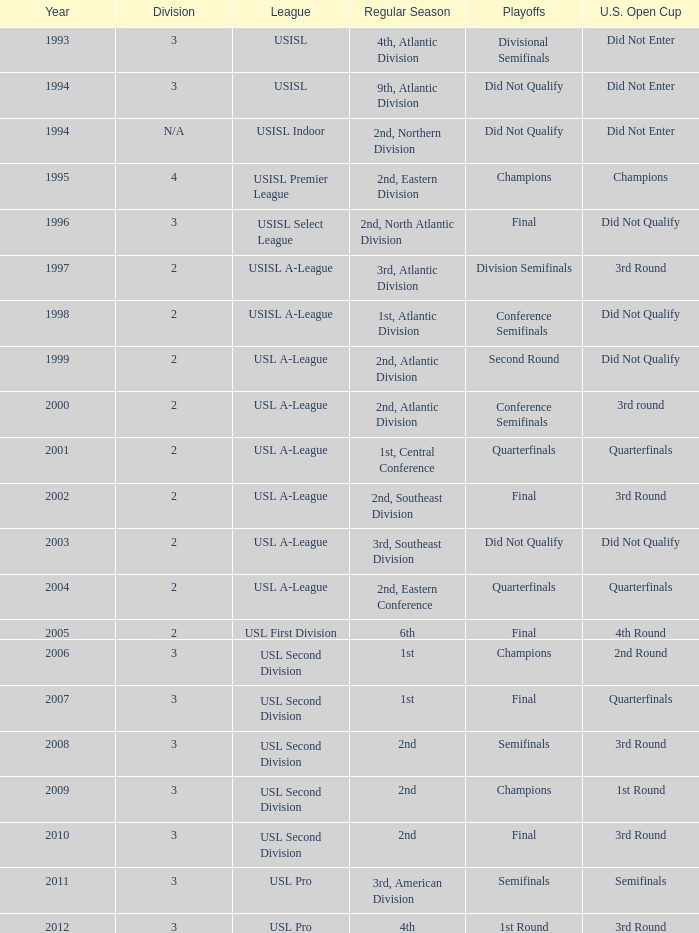Can you list the 1st round playoff games for the u.s. open cup? Champions. Write the full table. {'header': ['Year', 'Division', 'League', 'Regular Season', 'Playoffs', 'U.S. Open Cup'], 'rows': [['1993', '3', 'USISL', '4th, Atlantic Division', 'Divisional Semifinals', 'Did Not Enter'], ['1994', '3', 'USISL', '9th, Atlantic Division', 'Did Not Qualify', 'Did Not Enter'], ['1994', 'N/A', 'USISL Indoor', '2nd, Northern Division', 'Did Not Qualify', 'Did Not Enter'], ['1995', '4', 'USISL Premier League', '2nd, Eastern Division', 'Champions', 'Champions'], ['1996', '3', 'USISL Select League', '2nd, North Atlantic Division', 'Final', 'Did Not Qualify'], ['1997', '2', 'USISL A-League', '3rd, Atlantic Division', 'Division Semifinals', '3rd Round'], ['1998', '2', 'USISL A-League', '1st, Atlantic Division', 'Conference Semifinals', 'Did Not Qualify'], ['1999', '2', 'USL A-League', '2nd, Atlantic Division', 'Second Round', 'Did Not Qualify'], ['2000', '2', 'USL A-League', '2nd, Atlantic Division', 'Conference Semifinals', '3rd round'], ['2001', '2', 'USL A-League', '1st, Central Conference', 'Quarterfinals', 'Quarterfinals'], ['2002', '2', 'USL A-League', '2nd, Southeast Division', 'Final', '3rd Round'], ['2003', '2', 'USL A-League', '3rd, Southeast Division', 'Did Not Qualify', 'Did Not Qualify'], ['2004', '2', 'USL A-League', '2nd, Eastern Conference', 'Quarterfinals', 'Quarterfinals'], ['2005', '2', 'USL First Division', '6th', 'Final', '4th Round'], ['2006', '3', 'USL Second Division', '1st', 'Champions', '2nd Round'], ['2007', '3', 'USL Second Division', '1st', 'Final', 'Quarterfinals'], ['2008', '3', 'USL Second Division', '2nd', 'Semifinals', '3rd Round'], ['2009', '3', 'USL Second Division', '2nd', 'Champions', '1st Round'], ['2010', '3', 'USL Second Division', '2nd', 'Final', '3rd Round'], ['2011', '3', 'USL Pro', '3rd, American Division', 'Semifinals', 'Semifinals'], ['2012', '3', 'USL Pro', '4th', '1st Round', '3rd Round']]} 